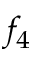<formula> <loc_0><loc_0><loc_500><loc_500>f _ { 4 }</formula> 